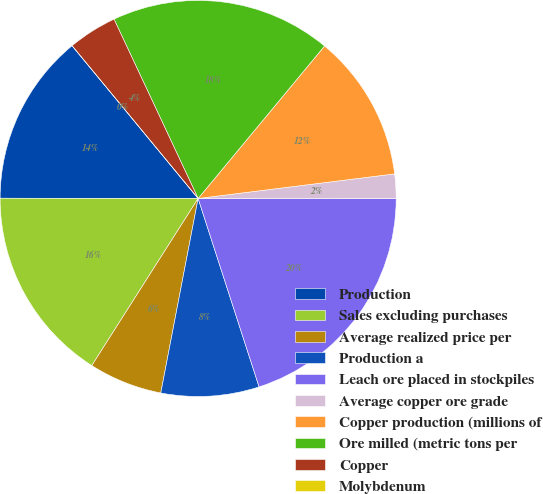<chart> <loc_0><loc_0><loc_500><loc_500><pie_chart><fcel>Production<fcel>Sales excluding purchases<fcel>Average realized price per<fcel>Production a<fcel>Leach ore placed in stockpiles<fcel>Average copper ore grade<fcel>Copper production (millions of<fcel>Ore milled (metric tons per<fcel>Copper<fcel>Molybdenum<nl><fcel>14.0%<fcel>16.0%<fcel>6.0%<fcel>8.0%<fcel>20.0%<fcel>2.0%<fcel>12.0%<fcel>18.0%<fcel>4.0%<fcel>0.0%<nl></chart> 